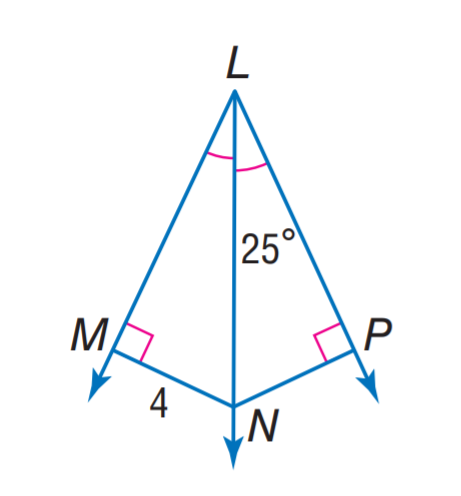Answer the mathemtical geometry problem and directly provide the correct option letter.
Question: Find m \angle M N P.
Choices: A: 40 B: 50 C: 130 D: 140 C 